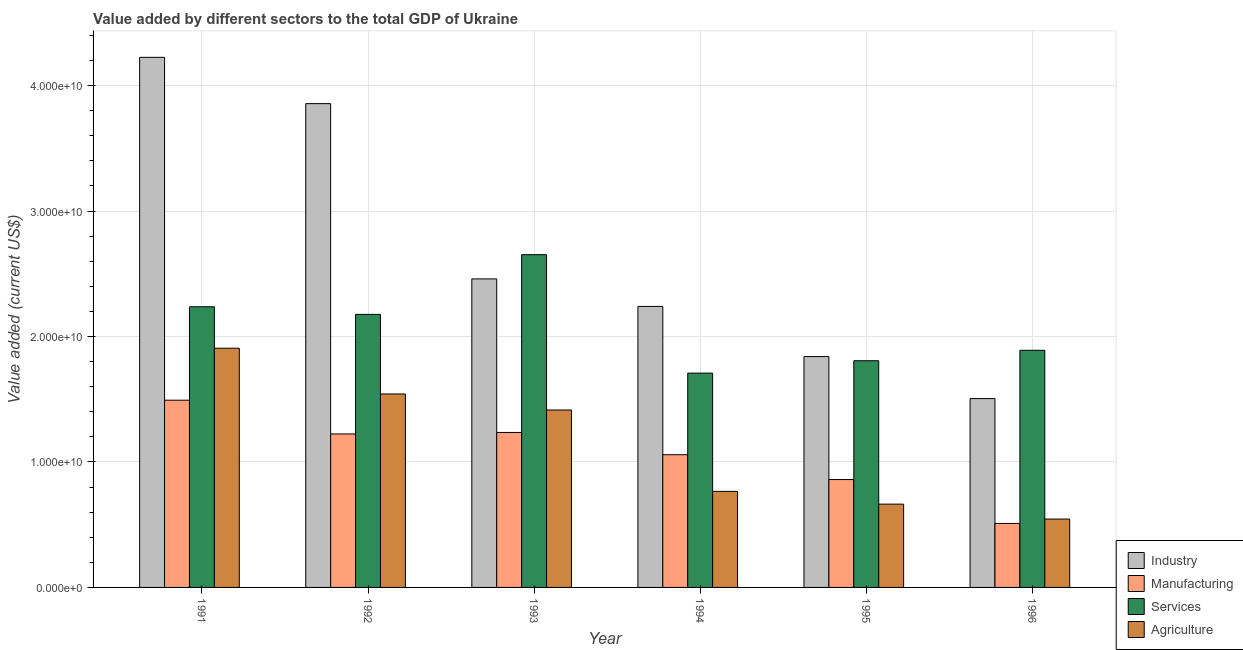How many different coloured bars are there?
Make the answer very short. 4. How many groups of bars are there?
Offer a terse response. 6. Are the number of bars on each tick of the X-axis equal?
Your answer should be very brief. Yes. How many bars are there on the 3rd tick from the left?
Offer a terse response. 4. How many bars are there on the 2nd tick from the right?
Offer a terse response. 4. What is the value added by manufacturing sector in 1995?
Your response must be concise. 8.60e+09. Across all years, what is the maximum value added by services sector?
Provide a succinct answer. 2.65e+1. Across all years, what is the minimum value added by services sector?
Give a very brief answer. 1.71e+1. In which year was the value added by manufacturing sector maximum?
Offer a very short reply. 1991. In which year was the value added by manufacturing sector minimum?
Provide a succinct answer. 1996. What is the total value added by industrial sector in the graph?
Your answer should be compact. 1.61e+11. What is the difference between the value added by services sector in 1991 and that in 1992?
Keep it short and to the point. 6.08e+08. What is the difference between the value added by industrial sector in 1992 and the value added by services sector in 1995?
Your answer should be compact. 2.02e+1. What is the average value added by manufacturing sector per year?
Your answer should be very brief. 1.06e+1. In the year 1995, what is the difference between the value added by industrial sector and value added by manufacturing sector?
Your answer should be very brief. 0. In how many years, is the value added by agricultural sector greater than 42000000000 US$?
Give a very brief answer. 0. What is the ratio of the value added by agricultural sector in 1993 to that in 1995?
Provide a short and direct response. 2.13. Is the value added by manufacturing sector in 1991 less than that in 1995?
Offer a very short reply. No. Is the difference between the value added by industrial sector in 1992 and 1994 greater than the difference between the value added by manufacturing sector in 1992 and 1994?
Ensure brevity in your answer.  No. What is the difference between the highest and the second highest value added by manufacturing sector?
Make the answer very short. 2.57e+09. What is the difference between the highest and the lowest value added by industrial sector?
Ensure brevity in your answer.  2.72e+1. Is it the case that in every year, the sum of the value added by agricultural sector and value added by industrial sector is greater than the sum of value added by services sector and value added by manufacturing sector?
Offer a very short reply. No. What does the 4th bar from the left in 1995 represents?
Offer a terse response. Agriculture. What does the 3rd bar from the right in 1994 represents?
Keep it short and to the point. Manufacturing. How many bars are there?
Your answer should be compact. 24. How many years are there in the graph?
Give a very brief answer. 6. Does the graph contain any zero values?
Provide a succinct answer. No. Does the graph contain grids?
Your answer should be very brief. Yes. Where does the legend appear in the graph?
Keep it short and to the point. Bottom right. What is the title of the graph?
Provide a succinct answer. Value added by different sectors to the total GDP of Ukraine. Does "Negligence towards children" appear as one of the legend labels in the graph?
Offer a terse response. No. What is the label or title of the Y-axis?
Offer a very short reply. Value added (current US$). What is the Value added (current US$) of Industry in 1991?
Provide a short and direct response. 4.23e+1. What is the Value added (current US$) in Manufacturing in 1991?
Your answer should be compact. 1.49e+1. What is the Value added (current US$) of Services in 1991?
Make the answer very short. 2.24e+1. What is the Value added (current US$) in Agriculture in 1991?
Offer a terse response. 1.91e+1. What is the Value added (current US$) of Industry in 1992?
Your response must be concise. 3.86e+1. What is the Value added (current US$) of Manufacturing in 1992?
Keep it short and to the point. 1.22e+1. What is the Value added (current US$) in Services in 1992?
Offer a very short reply. 2.18e+1. What is the Value added (current US$) of Agriculture in 1992?
Your response must be concise. 1.54e+1. What is the Value added (current US$) of Industry in 1993?
Give a very brief answer. 2.46e+1. What is the Value added (current US$) of Manufacturing in 1993?
Keep it short and to the point. 1.24e+1. What is the Value added (current US$) of Services in 1993?
Your response must be concise. 2.65e+1. What is the Value added (current US$) in Agriculture in 1993?
Your answer should be compact. 1.41e+1. What is the Value added (current US$) in Industry in 1994?
Offer a terse response. 2.24e+1. What is the Value added (current US$) in Manufacturing in 1994?
Offer a very short reply. 1.06e+1. What is the Value added (current US$) in Services in 1994?
Your response must be concise. 1.71e+1. What is the Value added (current US$) of Agriculture in 1994?
Ensure brevity in your answer.  7.66e+09. What is the Value added (current US$) of Industry in 1995?
Your answer should be very brief. 1.84e+1. What is the Value added (current US$) in Manufacturing in 1995?
Keep it short and to the point. 8.60e+09. What is the Value added (current US$) in Services in 1995?
Offer a very short reply. 1.81e+1. What is the Value added (current US$) in Agriculture in 1995?
Provide a short and direct response. 6.64e+09. What is the Value added (current US$) of Industry in 1996?
Your answer should be very brief. 1.51e+1. What is the Value added (current US$) of Manufacturing in 1996?
Provide a succinct answer. 5.10e+09. What is the Value added (current US$) in Services in 1996?
Make the answer very short. 1.89e+1. What is the Value added (current US$) of Agriculture in 1996?
Provide a short and direct response. 5.45e+09. Across all years, what is the maximum Value added (current US$) in Industry?
Provide a short and direct response. 4.23e+1. Across all years, what is the maximum Value added (current US$) in Manufacturing?
Provide a short and direct response. 1.49e+1. Across all years, what is the maximum Value added (current US$) in Services?
Keep it short and to the point. 2.65e+1. Across all years, what is the maximum Value added (current US$) of Agriculture?
Keep it short and to the point. 1.91e+1. Across all years, what is the minimum Value added (current US$) in Industry?
Your answer should be very brief. 1.51e+1. Across all years, what is the minimum Value added (current US$) in Manufacturing?
Offer a very short reply. 5.10e+09. Across all years, what is the minimum Value added (current US$) in Services?
Your answer should be very brief. 1.71e+1. Across all years, what is the minimum Value added (current US$) in Agriculture?
Provide a short and direct response. 5.45e+09. What is the total Value added (current US$) in Industry in the graph?
Make the answer very short. 1.61e+11. What is the total Value added (current US$) in Manufacturing in the graph?
Keep it short and to the point. 6.38e+1. What is the total Value added (current US$) in Services in the graph?
Give a very brief answer. 1.25e+11. What is the total Value added (current US$) of Agriculture in the graph?
Your answer should be very brief. 6.84e+1. What is the difference between the Value added (current US$) in Industry in 1991 and that in 1992?
Provide a short and direct response. 3.69e+09. What is the difference between the Value added (current US$) of Manufacturing in 1991 and that in 1992?
Offer a very short reply. 2.69e+09. What is the difference between the Value added (current US$) in Services in 1991 and that in 1992?
Your answer should be compact. 6.08e+08. What is the difference between the Value added (current US$) of Agriculture in 1991 and that in 1992?
Your answer should be very brief. 3.65e+09. What is the difference between the Value added (current US$) in Industry in 1991 and that in 1993?
Provide a succinct answer. 1.77e+1. What is the difference between the Value added (current US$) in Manufacturing in 1991 and that in 1993?
Your answer should be compact. 2.57e+09. What is the difference between the Value added (current US$) in Services in 1991 and that in 1993?
Give a very brief answer. -4.15e+09. What is the difference between the Value added (current US$) of Agriculture in 1991 and that in 1993?
Keep it short and to the point. 4.92e+09. What is the difference between the Value added (current US$) of Industry in 1991 and that in 1994?
Ensure brevity in your answer.  1.99e+1. What is the difference between the Value added (current US$) in Manufacturing in 1991 and that in 1994?
Your response must be concise. 4.34e+09. What is the difference between the Value added (current US$) in Services in 1991 and that in 1994?
Keep it short and to the point. 5.29e+09. What is the difference between the Value added (current US$) of Agriculture in 1991 and that in 1994?
Offer a terse response. 1.14e+1. What is the difference between the Value added (current US$) in Industry in 1991 and that in 1995?
Your answer should be very brief. 2.39e+1. What is the difference between the Value added (current US$) of Manufacturing in 1991 and that in 1995?
Provide a short and direct response. 6.32e+09. What is the difference between the Value added (current US$) in Services in 1991 and that in 1995?
Ensure brevity in your answer.  4.30e+09. What is the difference between the Value added (current US$) in Agriculture in 1991 and that in 1995?
Keep it short and to the point. 1.24e+1. What is the difference between the Value added (current US$) of Industry in 1991 and that in 1996?
Provide a short and direct response. 2.72e+1. What is the difference between the Value added (current US$) in Manufacturing in 1991 and that in 1996?
Keep it short and to the point. 9.82e+09. What is the difference between the Value added (current US$) of Services in 1991 and that in 1996?
Your response must be concise. 3.47e+09. What is the difference between the Value added (current US$) in Agriculture in 1991 and that in 1996?
Offer a very short reply. 1.36e+1. What is the difference between the Value added (current US$) in Industry in 1992 and that in 1993?
Provide a short and direct response. 1.40e+1. What is the difference between the Value added (current US$) of Manufacturing in 1992 and that in 1993?
Make the answer very short. -1.18e+08. What is the difference between the Value added (current US$) of Services in 1992 and that in 1993?
Provide a short and direct response. -4.76e+09. What is the difference between the Value added (current US$) of Agriculture in 1992 and that in 1993?
Your response must be concise. 1.28e+09. What is the difference between the Value added (current US$) in Industry in 1992 and that in 1994?
Keep it short and to the point. 1.62e+1. What is the difference between the Value added (current US$) in Manufacturing in 1992 and that in 1994?
Make the answer very short. 1.65e+09. What is the difference between the Value added (current US$) of Services in 1992 and that in 1994?
Offer a very short reply. 4.68e+09. What is the difference between the Value added (current US$) in Agriculture in 1992 and that in 1994?
Give a very brief answer. 7.76e+09. What is the difference between the Value added (current US$) in Industry in 1992 and that in 1995?
Keep it short and to the point. 2.02e+1. What is the difference between the Value added (current US$) in Manufacturing in 1992 and that in 1995?
Make the answer very short. 3.63e+09. What is the difference between the Value added (current US$) of Services in 1992 and that in 1995?
Your answer should be compact. 3.70e+09. What is the difference between the Value added (current US$) in Agriculture in 1992 and that in 1995?
Make the answer very short. 8.78e+09. What is the difference between the Value added (current US$) of Industry in 1992 and that in 1996?
Offer a very short reply. 2.35e+1. What is the difference between the Value added (current US$) of Manufacturing in 1992 and that in 1996?
Make the answer very short. 7.13e+09. What is the difference between the Value added (current US$) in Services in 1992 and that in 1996?
Your answer should be very brief. 2.86e+09. What is the difference between the Value added (current US$) in Agriculture in 1992 and that in 1996?
Provide a short and direct response. 9.97e+09. What is the difference between the Value added (current US$) in Industry in 1993 and that in 1994?
Ensure brevity in your answer.  2.19e+09. What is the difference between the Value added (current US$) of Manufacturing in 1993 and that in 1994?
Offer a terse response. 1.77e+09. What is the difference between the Value added (current US$) of Services in 1993 and that in 1994?
Offer a very short reply. 9.44e+09. What is the difference between the Value added (current US$) of Agriculture in 1993 and that in 1994?
Offer a very short reply. 6.48e+09. What is the difference between the Value added (current US$) in Industry in 1993 and that in 1995?
Keep it short and to the point. 6.19e+09. What is the difference between the Value added (current US$) in Manufacturing in 1993 and that in 1995?
Provide a short and direct response. 3.75e+09. What is the difference between the Value added (current US$) of Services in 1993 and that in 1995?
Offer a terse response. 8.46e+09. What is the difference between the Value added (current US$) of Agriculture in 1993 and that in 1995?
Make the answer very short. 7.50e+09. What is the difference between the Value added (current US$) of Industry in 1993 and that in 1996?
Your answer should be compact. 9.54e+09. What is the difference between the Value added (current US$) in Manufacturing in 1993 and that in 1996?
Ensure brevity in your answer.  7.25e+09. What is the difference between the Value added (current US$) in Services in 1993 and that in 1996?
Your answer should be very brief. 7.62e+09. What is the difference between the Value added (current US$) of Agriculture in 1993 and that in 1996?
Keep it short and to the point. 8.69e+09. What is the difference between the Value added (current US$) in Industry in 1994 and that in 1995?
Offer a terse response. 4.00e+09. What is the difference between the Value added (current US$) in Manufacturing in 1994 and that in 1995?
Give a very brief answer. 1.98e+09. What is the difference between the Value added (current US$) in Services in 1994 and that in 1995?
Your answer should be compact. -9.86e+08. What is the difference between the Value added (current US$) of Agriculture in 1994 and that in 1995?
Your answer should be very brief. 1.02e+09. What is the difference between the Value added (current US$) in Industry in 1994 and that in 1996?
Your response must be concise. 7.35e+09. What is the difference between the Value added (current US$) of Manufacturing in 1994 and that in 1996?
Keep it short and to the point. 5.48e+09. What is the difference between the Value added (current US$) in Services in 1994 and that in 1996?
Give a very brief answer. -1.82e+09. What is the difference between the Value added (current US$) of Agriculture in 1994 and that in 1996?
Make the answer very short. 2.21e+09. What is the difference between the Value added (current US$) of Industry in 1995 and that in 1996?
Offer a very short reply. 3.35e+09. What is the difference between the Value added (current US$) in Manufacturing in 1995 and that in 1996?
Keep it short and to the point. 3.50e+09. What is the difference between the Value added (current US$) in Services in 1995 and that in 1996?
Your answer should be very brief. -8.33e+08. What is the difference between the Value added (current US$) in Agriculture in 1995 and that in 1996?
Ensure brevity in your answer.  1.19e+09. What is the difference between the Value added (current US$) of Industry in 1991 and the Value added (current US$) of Manufacturing in 1992?
Give a very brief answer. 3.00e+1. What is the difference between the Value added (current US$) of Industry in 1991 and the Value added (current US$) of Services in 1992?
Offer a terse response. 2.05e+1. What is the difference between the Value added (current US$) of Industry in 1991 and the Value added (current US$) of Agriculture in 1992?
Provide a succinct answer. 2.68e+1. What is the difference between the Value added (current US$) in Manufacturing in 1991 and the Value added (current US$) in Services in 1992?
Ensure brevity in your answer.  -6.84e+09. What is the difference between the Value added (current US$) in Manufacturing in 1991 and the Value added (current US$) in Agriculture in 1992?
Keep it short and to the point. -4.97e+08. What is the difference between the Value added (current US$) in Services in 1991 and the Value added (current US$) in Agriculture in 1992?
Offer a terse response. 6.95e+09. What is the difference between the Value added (current US$) in Industry in 1991 and the Value added (current US$) in Manufacturing in 1993?
Offer a very short reply. 2.99e+1. What is the difference between the Value added (current US$) of Industry in 1991 and the Value added (current US$) of Services in 1993?
Your answer should be very brief. 1.57e+1. What is the difference between the Value added (current US$) of Industry in 1991 and the Value added (current US$) of Agriculture in 1993?
Keep it short and to the point. 2.81e+1. What is the difference between the Value added (current US$) of Manufacturing in 1991 and the Value added (current US$) of Services in 1993?
Give a very brief answer. -1.16e+1. What is the difference between the Value added (current US$) of Manufacturing in 1991 and the Value added (current US$) of Agriculture in 1993?
Ensure brevity in your answer.  7.81e+08. What is the difference between the Value added (current US$) in Services in 1991 and the Value added (current US$) in Agriculture in 1993?
Your response must be concise. 8.23e+09. What is the difference between the Value added (current US$) in Industry in 1991 and the Value added (current US$) in Manufacturing in 1994?
Your answer should be very brief. 3.17e+1. What is the difference between the Value added (current US$) of Industry in 1991 and the Value added (current US$) of Services in 1994?
Your answer should be compact. 2.52e+1. What is the difference between the Value added (current US$) of Industry in 1991 and the Value added (current US$) of Agriculture in 1994?
Your answer should be very brief. 3.46e+1. What is the difference between the Value added (current US$) of Manufacturing in 1991 and the Value added (current US$) of Services in 1994?
Keep it short and to the point. -2.16e+09. What is the difference between the Value added (current US$) in Manufacturing in 1991 and the Value added (current US$) in Agriculture in 1994?
Offer a terse response. 7.27e+09. What is the difference between the Value added (current US$) of Services in 1991 and the Value added (current US$) of Agriculture in 1994?
Give a very brief answer. 1.47e+1. What is the difference between the Value added (current US$) of Industry in 1991 and the Value added (current US$) of Manufacturing in 1995?
Provide a short and direct response. 3.37e+1. What is the difference between the Value added (current US$) in Industry in 1991 and the Value added (current US$) in Services in 1995?
Your answer should be compact. 2.42e+1. What is the difference between the Value added (current US$) in Industry in 1991 and the Value added (current US$) in Agriculture in 1995?
Offer a terse response. 3.56e+1. What is the difference between the Value added (current US$) in Manufacturing in 1991 and the Value added (current US$) in Services in 1995?
Give a very brief answer. -3.15e+09. What is the difference between the Value added (current US$) in Manufacturing in 1991 and the Value added (current US$) in Agriculture in 1995?
Your answer should be compact. 8.28e+09. What is the difference between the Value added (current US$) in Services in 1991 and the Value added (current US$) in Agriculture in 1995?
Your answer should be compact. 1.57e+1. What is the difference between the Value added (current US$) in Industry in 1991 and the Value added (current US$) in Manufacturing in 1996?
Offer a very short reply. 3.72e+1. What is the difference between the Value added (current US$) of Industry in 1991 and the Value added (current US$) of Services in 1996?
Offer a very short reply. 2.34e+1. What is the difference between the Value added (current US$) of Industry in 1991 and the Value added (current US$) of Agriculture in 1996?
Offer a very short reply. 3.68e+1. What is the difference between the Value added (current US$) in Manufacturing in 1991 and the Value added (current US$) in Services in 1996?
Offer a terse response. -3.98e+09. What is the difference between the Value added (current US$) of Manufacturing in 1991 and the Value added (current US$) of Agriculture in 1996?
Make the answer very short. 9.47e+09. What is the difference between the Value added (current US$) of Services in 1991 and the Value added (current US$) of Agriculture in 1996?
Offer a very short reply. 1.69e+1. What is the difference between the Value added (current US$) in Industry in 1992 and the Value added (current US$) in Manufacturing in 1993?
Offer a very short reply. 2.62e+1. What is the difference between the Value added (current US$) in Industry in 1992 and the Value added (current US$) in Services in 1993?
Offer a very short reply. 1.20e+1. What is the difference between the Value added (current US$) of Industry in 1992 and the Value added (current US$) of Agriculture in 1993?
Your answer should be very brief. 2.44e+1. What is the difference between the Value added (current US$) of Manufacturing in 1992 and the Value added (current US$) of Services in 1993?
Your answer should be very brief. -1.43e+1. What is the difference between the Value added (current US$) of Manufacturing in 1992 and the Value added (current US$) of Agriculture in 1993?
Your answer should be very brief. -1.91e+09. What is the difference between the Value added (current US$) in Services in 1992 and the Value added (current US$) in Agriculture in 1993?
Your answer should be very brief. 7.62e+09. What is the difference between the Value added (current US$) in Industry in 1992 and the Value added (current US$) in Manufacturing in 1994?
Offer a very short reply. 2.80e+1. What is the difference between the Value added (current US$) of Industry in 1992 and the Value added (current US$) of Services in 1994?
Offer a very short reply. 2.15e+1. What is the difference between the Value added (current US$) of Industry in 1992 and the Value added (current US$) of Agriculture in 1994?
Give a very brief answer. 3.09e+1. What is the difference between the Value added (current US$) of Manufacturing in 1992 and the Value added (current US$) of Services in 1994?
Keep it short and to the point. -4.85e+09. What is the difference between the Value added (current US$) of Manufacturing in 1992 and the Value added (current US$) of Agriculture in 1994?
Give a very brief answer. 4.58e+09. What is the difference between the Value added (current US$) in Services in 1992 and the Value added (current US$) in Agriculture in 1994?
Offer a terse response. 1.41e+1. What is the difference between the Value added (current US$) of Industry in 1992 and the Value added (current US$) of Manufacturing in 1995?
Your answer should be compact. 3.00e+1. What is the difference between the Value added (current US$) in Industry in 1992 and the Value added (current US$) in Services in 1995?
Keep it short and to the point. 2.05e+1. What is the difference between the Value added (current US$) in Industry in 1992 and the Value added (current US$) in Agriculture in 1995?
Keep it short and to the point. 3.19e+1. What is the difference between the Value added (current US$) in Manufacturing in 1992 and the Value added (current US$) in Services in 1995?
Your response must be concise. -5.84e+09. What is the difference between the Value added (current US$) of Manufacturing in 1992 and the Value added (current US$) of Agriculture in 1995?
Give a very brief answer. 5.59e+09. What is the difference between the Value added (current US$) in Services in 1992 and the Value added (current US$) in Agriculture in 1995?
Your answer should be compact. 1.51e+1. What is the difference between the Value added (current US$) of Industry in 1992 and the Value added (current US$) of Manufacturing in 1996?
Your answer should be compact. 3.35e+1. What is the difference between the Value added (current US$) of Industry in 1992 and the Value added (current US$) of Services in 1996?
Give a very brief answer. 1.97e+1. What is the difference between the Value added (current US$) of Industry in 1992 and the Value added (current US$) of Agriculture in 1996?
Provide a short and direct response. 3.31e+1. What is the difference between the Value added (current US$) in Manufacturing in 1992 and the Value added (current US$) in Services in 1996?
Your answer should be very brief. -6.67e+09. What is the difference between the Value added (current US$) of Manufacturing in 1992 and the Value added (current US$) of Agriculture in 1996?
Give a very brief answer. 6.78e+09. What is the difference between the Value added (current US$) of Services in 1992 and the Value added (current US$) of Agriculture in 1996?
Offer a terse response. 1.63e+1. What is the difference between the Value added (current US$) in Industry in 1993 and the Value added (current US$) in Manufacturing in 1994?
Offer a very short reply. 1.40e+1. What is the difference between the Value added (current US$) of Industry in 1993 and the Value added (current US$) of Services in 1994?
Offer a very short reply. 7.51e+09. What is the difference between the Value added (current US$) of Industry in 1993 and the Value added (current US$) of Agriculture in 1994?
Your response must be concise. 1.69e+1. What is the difference between the Value added (current US$) in Manufacturing in 1993 and the Value added (current US$) in Services in 1994?
Your answer should be compact. -4.73e+09. What is the difference between the Value added (current US$) in Manufacturing in 1993 and the Value added (current US$) in Agriculture in 1994?
Ensure brevity in your answer.  4.69e+09. What is the difference between the Value added (current US$) of Services in 1993 and the Value added (current US$) of Agriculture in 1994?
Offer a very short reply. 1.89e+1. What is the difference between the Value added (current US$) in Industry in 1993 and the Value added (current US$) in Manufacturing in 1995?
Offer a very short reply. 1.60e+1. What is the difference between the Value added (current US$) of Industry in 1993 and the Value added (current US$) of Services in 1995?
Your response must be concise. 6.52e+09. What is the difference between the Value added (current US$) in Industry in 1993 and the Value added (current US$) in Agriculture in 1995?
Your response must be concise. 1.80e+1. What is the difference between the Value added (current US$) of Manufacturing in 1993 and the Value added (current US$) of Services in 1995?
Offer a very short reply. -5.72e+09. What is the difference between the Value added (current US$) of Manufacturing in 1993 and the Value added (current US$) of Agriculture in 1995?
Keep it short and to the point. 5.71e+09. What is the difference between the Value added (current US$) of Services in 1993 and the Value added (current US$) of Agriculture in 1995?
Offer a terse response. 1.99e+1. What is the difference between the Value added (current US$) in Industry in 1993 and the Value added (current US$) in Manufacturing in 1996?
Keep it short and to the point. 1.95e+1. What is the difference between the Value added (current US$) of Industry in 1993 and the Value added (current US$) of Services in 1996?
Your response must be concise. 5.69e+09. What is the difference between the Value added (current US$) of Industry in 1993 and the Value added (current US$) of Agriculture in 1996?
Your response must be concise. 1.91e+1. What is the difference between the Value added (current US$) of Manufacturing in 1993 and the Value added (current US$) of Services in 1996?
Provide a short and direct response. -6.55e+09. What is the difference between the Value added (current US$) in Manufacturing in 1993 and the Value added (current US$) in Agriculture in 1996?
Your answer should be compact. 6.90e+09. What is the difference between the Value added (current US$) in Services in 1993 and the Value added (current US$) in Agriculture in 1996?
Provide a succinct answer. 2.11e+1. What is the difference between the Value added (current US$) of Industry in 1994 and the Value added (current US$) of Manufacturing in 1995?
Offer a terse response. 1.38e+1. What is the difference between the Value added (current US$) in Industry in 1994 and the Value added (current US$) in Services in 1995?
Offer a terse response. 4.33e+09. What is the difference between the Value added (current US$) of Industry in 1994 and the Value added (current US$) of Agriculture in 1995?
Your response must be concise. 1.58e+1. What is the difference between the Value added (current US$) of Manufacturing in 1994 and the Value added (current US$) of Services in 1995?
Offer a very short reply. -7.49e+09. What is the difference between the Value added (current US$) in Manufacturing in 1994 and the Value added (current US$) in Agriculture in 1995?
Your response must be concise. 3.94e+09. What is the difference between the Value added (current US$) of Services in 1994 and the Value added (current US$) of Agriculture in 1995?
Give a very brief answer. 1.04e+1. What is the difference between the Value added (current US$) of Industry in 1994 and the Value added (current US$) of Manufacturing in 1996?
Your answer should be very brief. 1.73e+1. What is the difference between the Value added (current US$) in Industry in 1994 and the Value added (current US$) in Services in 1996?
Ensure brevity in your answer.  3.50e+09. What is the difference between the Value added (current US$) of Industry in 1994 and the Value added (current US$) of Agriculture in 1996?
Offer a very short reply. 1.69e+1. What is the difference between the Value added (current US$) in Manufacturing in 1994 and the Value added (current US$) in Services in 1996?
Keep it short and to the point. -8.32e+09. What is the difference between the Value added (current US$) of Manufacturing in 1994 and the Value added (current US$) of Agriculture in 1996?
Make the answer very short. 5.13e+09. What is the difference between the Value added (current US$) in Services in 1994 and the Value added (current US$) in Agriculture in 1996?
Give a very brief answer. 1.16e+1. What is the difference between the Value added (current US$) of Industry in 1995 and the Value added (current US$) of Manufacturing in 1996?
Give a very brief answer. 1.33e+1. What is the difference between the Value added (current US$) in Industry in 1995 and the Value added (current US$) in Services in 1996?
Make the answer very short. -5.02e+08. What is the difference between the Value added (current US$) in Industry in 1995 and the Value added (current US$) in Agriculture in 1996?
Your response must be concise. 1.30e+1. What is the difference between the Value added (current US$) in Manufacturing in 1995 and the Value added (current US$) in Services in 1996?
Keep it short and to the point. -1.03e+1. What is the difference between the Value added (current US$) of Manufacturing in 1995 and the Value added (current US$) of Agriculture in 1996?
Make the answer very short. 3.15e+09. What is the difference between the Value added (current US$) in Services in 1995 and the Value added (current US$) in Agriculture in 1996?
Keep it short and to the point. 1.26e+1. What is the average Value added (current US$) in Industry per year?
Provide a short and direct response. 2.69e+1. What is the average Value added (current US$) of Manufacturing per year?
Make the answer very short. 1.06e+1. What is the average Value added (current US$) in Services per year?
Provide a short and direct response. 2.08e+1. What is the average Value added (current US$) in Agriculture per year?
Ensure brevity in your answer.  1.14e+1. In the year 1991, what is the difference between the Value added (current US$) of Industry and Value added (current US$) of Manufacturing?
Provide a short and direct response. 2.73e+1. In the year 1991, what is the difference between the Value added (current US$) in Industry and Value added (current US$) in Services?
Provide a short and direct response. 1.99e+1. In the year 1991, what is the difference between the Value added (current US$) of Industry and Value added (current US$) of Agriculture?
Your response must be concise. 2.32e+1. In the year 1991, what is the difference between the Value added (current US$) in Manufacturing and Value added (current US$) in Services?
Provide a short and direct response. -7.45e+09. In the year 1991, what is the difference between the Value added (current US$) in Manufacturing and Value added (current US$) in Agriculture?
Your answer should be compact. -4.14e+09. In the year 1991, what is the difference between the Value added (current US$) of Services and Value added (current US$) of Agriculture?
Give a very brief answer. 3.31e+09. In the year 1992, what is the difference between the Value added (current US$) of Industry and Value added (current US$) of Manufacturing?
Your answer should be compact. 2.63e+1. In the year 1992, what is the difference between the Value added (current US$) of Industry and Value added (current US$) of Services?
Your response must be concise. 1.68e+1. In the year 1992, what is the difference between the Value added (current US$) in Industry and Value added (current US$) in Agriculture?
Your answer should be compact. 2.31e+1. In the year 1992, what is the difference between the Value added (current US$) of Manufacturing and Value added (current US$) of Services?
Keep it short and to the point. -9.53e+09. In the year 1992, what is the difference between the Value added (current US$) of Manufacturing and Value added (current US$) of Agriculture?
Your answer should be very brief. -3.19e+09. In the year 1992, what is the difference between the Value added (current US$) of Services and Value added (current US$) of Agriculture?
Keep it short and to the point. 6.35e+09. In the year 1993, what is the difference between the Value added (current US$) of Industry and Value added (current US$) of Manufacturing?
Ensure brevity in your answer.  1.22e+1. In the year 1993, what is the difference between the Value added (current US$) in Industry and Value added (current US$) in Services?
Your answer should be compact. -1.93e+09. In the year 1993, what is the difference between the Value added (current US$) in Industry and Value added (current US$) in Agriculture?
Provide a short and direct response. 1.05e+1. In the year 1993, what is the difference between the Value added (current US$) in Manufacturing and Value added (current US$) in Services?
Your answer should be very brief. -1.42e+1. In the year 1993, what is the difference between the Value added (current US$) in Manufacturing and Value added (current US$) in Agriculture?
Provide a succinct answer. -1.79e+09. In the year 1993, what is the difference between the Value added (current US$) in Services and Value added (current US$) in Agriculture?
Provide a short and direct response. 1.24e+1. In the year 1994, what is the difference between the Value added (current US$) of Industry and Value added (current US$) of Manufacturing?
Keep it short and to the point. 1.18e+1. In the year 1994, what is the difference between the Value added (current US$) in Industry and Value added (current US$) in Services?
Ensure brevity in your answer.  5.32e+09. In the year 1994, what is the difference between the Value added (current US$) of Industry and Value added (current US$) of Agriculture?
Provide a succinct answer. 1.47e+1. In the year 1994, what is the difference between the Value added (current US$) of Manufacturing and Value added (current US$) of Services?
Your answer should be very brief. -6.50e+09. In the year 1994, what is the difference between the Value added (current US$) of Manufacturing and Value added (current US$) of Agriculture?
Your answer should be compact. 2.92e+09. In the year 1994, what is the difference between the Value added (current US$) in Services and Value added (current US$) in Agriculture?
Offer a terse response. 9.43e+09. In the year 1995, what is the difference between the Value added (current US$) of Industry and Value added (current US$) of Manufacturing?
Offer a terse response. 9.80e+09. In the year 1995, what is the difference between the Value added (current US$) of Industry and Value added (current US$) of Services?
Your answer should be very brief. 3.32e+08. In the year 1995, what is the difference between the Value added (current US$) of Industry and Value added (current US$) of Agriculture?
Ensure brevity in your answer.  1.18e+1. In the year 1995, what is the difference between the Value added (current US$) in Manufacturing and Value added (current US$) in Services?
Your answer should be compact. -9.47e+09. In the year 1995, what is the difference between the Value added (current US$) in Manufacturing and Value added (current US$) in Agriculture?
Ensure brevity in your answer.  1.96e+09. In the year 1995, what is the difference between the Value added (current US$) in Services and Value added (current US$) in Agriculture?
Your answer should be very brief. 1.14e+1. In the year 1996, what is the difference between the Value added (current US$) in Industry and Value added (current US$) in Manufacturing?
Your response must be concise. 9.95e+09. In the year 1996, what is the difference between the Value added (current US$) in Industry and Value added (current US$) in Services?
Offer a terse response. -3.85e+09. In the year 1996, what is the difference between the Value added (current US$) of Industry and Value added (current US$) of Agriculture?
Give a very brief answer. 9.60e+09. In the year 1996, what is the difference between the Value added (current US$) in Manufacturing and Value added (current US$) in Services?
Make the answer very short. -1.38e+1. In the year 1996, what is the difference between the Value added (current US$) of Manufacturing and Value added (current US$) of Agriculture?
Ensure brevity in your answer.  -3.50e+08. In the year 1996, what is the difference between the Value added (current US$) in Services and Value added (current US$) in Agriculture?
Provide a short and direct response. 1.35e+1. What is the ratio of the Value added (current US$) of Industry in 1991 to that in 1992?
Ensure brevity in your answer.  1.1. What is the ratio of the Value added (current US$) of Manufacturing in 1991 to that in 1992?
Ensure brevity in your answer.  1.22. What is the ratio of the Value added (current US$) in Services in 1991 to that in 1992?
Make the answer very short. 1.03. What is the ratio of the Value added (current US$) in Agriculture in 1991 to that in 1992?
Offer a terse response. 1.24. What is the ratio of the Value added (current US$) of Industry in 1991 to that in 1993?
Offer a very short reply. 1.72. What is the ratio of the Value added (current US$) of Manufacturing in 1991 to that in 1993?
Give a very brief answer. 1.21. What is the ratio of the Value added (current US$) of Services in 1991 to that in 1993?
Offer a terse response. 0.84. What is the ratio of the Value added (current US$) of Agriculture in 1991 to that in 1993?
Offer a very short reply. 1.35. What is the ratio of the Value added (current US$) of Industry in 1991 to that in 1994?
Your answer should be compact. 1.89. What is the ratio of the Value added (current US$) of Manufacturing in 1991 to that in 1994?
Offer a very short reply. 1.41. What is the ratio of the Value added (current US$) in Services in 1991 to that in 1994?
Provide a succinct answer. 1.31. What is the ratio of the Value added (current US$) of Agriculture in 1991 to that in 1994?
Provide a short and direct response. 2.49. What is the ratio of the Value added (current US$) of Industry in 1991 to that in 1995?
Offer a very short reply. 2.3. What is the ratio of the Value added (current US$) of Manufacturing in 1991 to that in 1995?
Your response must be concise. 1.74. What is the ratio of the Value added (current US$) in Services in 1991 to that in 1995?
Make the answer very short. 1.24. What is the ratio of the Value added (current US$) of Agriculture in 1991 to that in 1995?
Your answer should be very brief. 2.87. What is the ratio of the Value added (current US$) of Industry in 1991 to that in 1996?
Your answer should be very brief. 2.81. What is the ratio of the Value added (current US$) in Manufacturing in 1991 to that in 1996?
Make the answer very short. 2.93. What is the ratio of the Value added (current US$) in Services in 1991 to that in 1996?
Offer a terse response. 1.18. What is the ratio of the Value added (current US$) in Agriculture in 1991 to that in 1996?
Provide a succinct answer. 3.5. What is the ratio of the Value added (current US$) in Industry in 1992 to that in 1993?
Offer a terse response. 1.57. What is the ratio of the Value added (current US$) in Manufacturing in 1992 to that in 1993?
Your response must be concise. 0.99. What is the ratio of the Value added (current US$) in Services in 1992 to that in 1993?
Keep it short and to the point. 0.82. What is the ratio of the Value added (current US$) in Agriculture in 1992 to that in 1993?
Give a very brief answer. 1.09. What is the ratio of the Value added (current US$) in Industry in 1992 to that in 1994?
Provide a succinct answer. 1.72. What is the ratio of the Value added (current US$) of Manufacturing in 1992 to that in 1994?
Ensure brevity in your answer.  1.16. What is the ratio of the Value added (current US$) of Services in 1992 to that in 1994?
Your response must be concise. 1.27. What is the ratio of the Value added (current US$) in Agriculture in 1992 to that in 1994?
Provide a succinct answer. 2.01. What is the ratio of the Value added (current US$) of Industry in 1992 to that in 1995?
Your response must be concise. 2.1. What is the ratio of the Value added (current US$) in Manufacturing in 1992 to that in 1995?
Give a very brief answer. 1.42. What is the ratio of the Value added (current US$) in Services in 1992 to that in 1995?
Ensure brevity in your answer.  1.2. What is the ratio of the Value added (current US$) in Agriculture in 1992 to that in 1995?
Offer a very short reply. 2.32. What is the ratio of the Value added (current US$) in Industry in 1992 to that in 1996?
Your answer should be compact. 2.56. What is the ratio of the Value added (current US$) in Manufacturing in 1992 to that in 1996?
Make the answer very short. 2.4. What is the ratio of the Value added (current US$) of Services in 1992 to that in 1996?
Offer a terse response. 1.15. What is the ratio of the Value added (current US$) in Agriculture in 1992 to that in 1996?
Provide a succinct answer. 2.83. What is the ratio of the Value added (current US$) in Industry in 1993 to that in 1994?
Make the answer very short. 1.1. What is the ratio of the Value added (current US$) in Manufacturing in 1993 to that in 1994?
Offer a terse response. 1.17. What is the ratio of the Value added (current US$) of Services in 1993 to that in 1994?
Your answer should be very brief. 1.55. What is the ratio of the Value added (current US$) of Agriculture in 1993 to that in 1994?
Provide a succinct answer. 1.85. What is the ratio of the Value added (current US$) of Industry in 1993 to that in 1995?
Offer a very short reply. 1.34. What is the ratio of the Value added (current US$) in Manufacturing in 1993 to that in 1995?
Keep it short and to the point. 1.44. What is the ratio of the Value added (current US$) of Services in 1993 to that in 1995?
Your answer should be very brief. 1.47. What is the ratio of the Value added (current US$) of Agriculture in 1993 to that in 1995?
Ensure brevity in your answer.  2.13. What is the ratio of the Value added (current US$) in Industry in 1993 to that in 1996?
Offer a very short reply. 1.63. What is the ratio of the Value added (current US$) of Manufacturing in 1993 to that in 1996?
Make the answer very short. 2.42. What is the ratio of the Value added (current US$) of Services in 1993 to that in 1996?
Keep it short and to the point. 1.4. What is the ratio of the Value added (current US$) of Agriculture in 1993 to that in 1996?
Make the answer very short. 2.6. What is the ratio of the Value added (current US$) in Industry in 1994 to that in 1995?
Your response must be concise. 1.22. What is the ratio of the Value added (current US$) in Manufacturing in 1994 to that in 1995?
Provide a short and direct response. 1.23. What is the ratio of the Value added (current US$) of Services in 1994 to that in 1995?
Your answer should be very brief. 0.95. What is the ratio of the Value added (current US$) in Agriculture in 1994 to that in 1995?
Your answer should be compact. 1.15. What is the ratio of the Value added (current US$) in Industry in 1994 to that in 1996?
Ensure brevity in your answer.  1.49. What is the ratio of the Value added (current US$) of Manufacturing in 1994 to that in 1996?
Provide a succinct answer. 2.07. What is the ratio of the Value added (current US$) of Services in 1994 to that in 1996?
Ensure brevity in your answer.  0.9. What is the ratio of the Value added (current US$) of Agriculture in 1994 to that in 1996?
Make the answer very short. 1.41. What is the ratio of the Value added (current US$) in Industry in 1995 to that in 1996?
Offer a terse response. 1.22. What is the ratio of the Value added (current US$) of Manufacturing in 1995 to that in 1996?
Your response must be concise. 1.69. What is the ratio of the Value added (current US$) of Services in 1995 to that in 1996?
Keep it short and to the point. 0.96. What is the ratio of the Value added (current US$) in Agriculture in 1995 to that in 1996?
Ensure brevity in your answer.  1.22. What is the difference between the highest and the second highest Value added (current US$) in Industry?
Provide a succinct answer. 3.69e+09. What is the difference between the highest and the second highest Value added (current US$) of Manufacturing?
Give a very brief answer. 2.57e+09. What is the difference between the highest and the second highest Value added (current US$) of Services?
Keep it short and to the point. 4.15e+09. What is the difference between the highest and the second highest Value added (current US$) in Agriculture?
Offer a terse response. 3.65e+09. What is the difference between the highest and the lowest Value added (current US$) of Industry?
Your answer should be compact. 2.72e+1. What is the difference between the highest and the lowest Value added (current US$) in Manufacturing?
Your answer should be very brief. 9.82e+09. What is the difference between the highest and the lowest Value added (current US$) of Services?
Offer a terse response. 9.44e+09. What is the difference between the highest and the lowest Value added (current US$) of Agriculture?
Offer a terse response. 1.36e+1. 